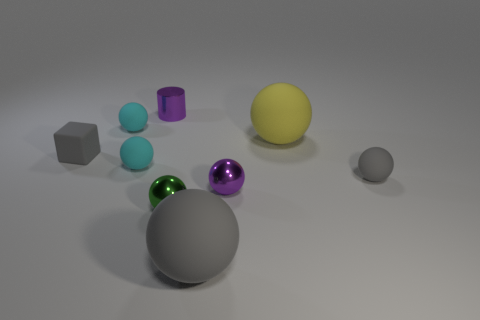There is a cyan thing in front of the yellow rubber thing; is its size the same as the large yellow matte object?
Offer a terse response. No. What material is the small thing that is in front of the purple ball in front of the large sphere behind the tiny gray rubber cube made of?
Give a very brief answer. Metal. There is a big matte sphere in front of the yellow matte object; is its color the same as the small matte sphere that is on the right side of the large gray rubber ball?
Provide a succinct answer. Yes. What is the material of the tiny purple object right of the tiny metallic thing that is behind the yellow matte sphere?
Provide a succinct answer. Metal. The metal cylinder that is the same size as the gray cube is what color?
Ensure brevity in your answer.  Purple. Do the tiny green object and the tiny rubber thing on the right side of the green sphere have the same shape?
Your response must be concise. Yes. What shape is the small matte thing that is the same color as the block?
Ensure brevity in your answer.  Sphere. What number of purple metal spheres are on the left side of the tiny metallic object that is behind the small gray matte object that is on the left side of the tiny green metallic object?
Offer a terse response. 0. What size is the yellow rubber thing that is right of the small purple metal object behind the yellow object?
Your answer should be compact. Large. The gray cube that is made of the same material as the yellow sphere is what size?
Your response must be concise. Small. 